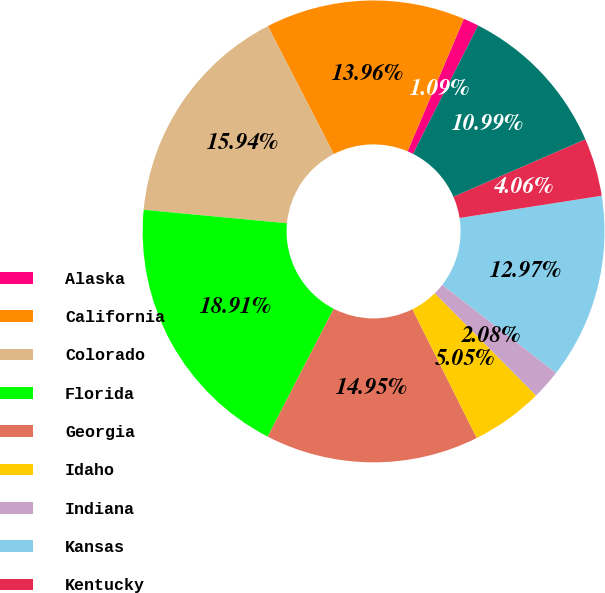Convert chart to OTSL. <chart><loc_0><loc_0><loc_500><loc_500><pie_chart><fcel>Alaska<fcel>California<fcel>Colorado<fcel>Florida<fcel>Georgia<fcel>Idaho<fcel>Indiana<fcel>Kansas<fcel>Kentucky<fcel>Louisiana<nl><fcel>1.09%<fcel>13.96%<fcel>15.94%<fcel>18.91%<fcel>14.95%<fcel>5.05%<fcel>2.08%<fcel>12.97%<fcel>4.06%<fcel>10.99%<nl></chart> 